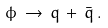Convert formula to latex. <formula><loc_0><loc_0><loc_500><loc_500>\phi \, \rightarrow \, q \, + \, \bar { q } \, .</formula> 